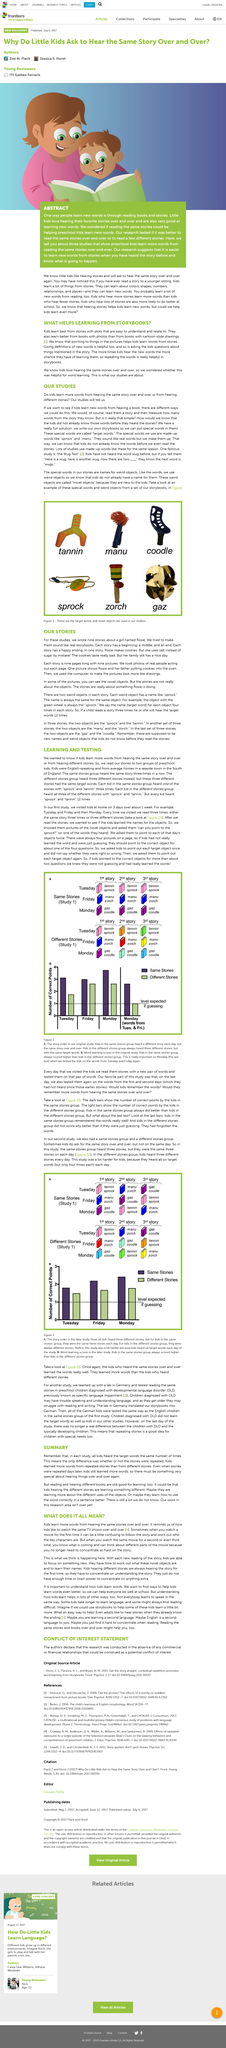Give some essential details in this illustration. In this study, a total of nine stories were written. Giving definitions to kids is considered helpful. Yes, when stories were repeated days later, the children still learned more words. The study aimed to determine whether children learn more words from hearing the same story repeatedly or from exposure to different stories. The illustration in the picture depicted a woman reading to a young child, which is discussed in detail in the article titled 'Abstract' as being one of the activities mentioned in the article. 